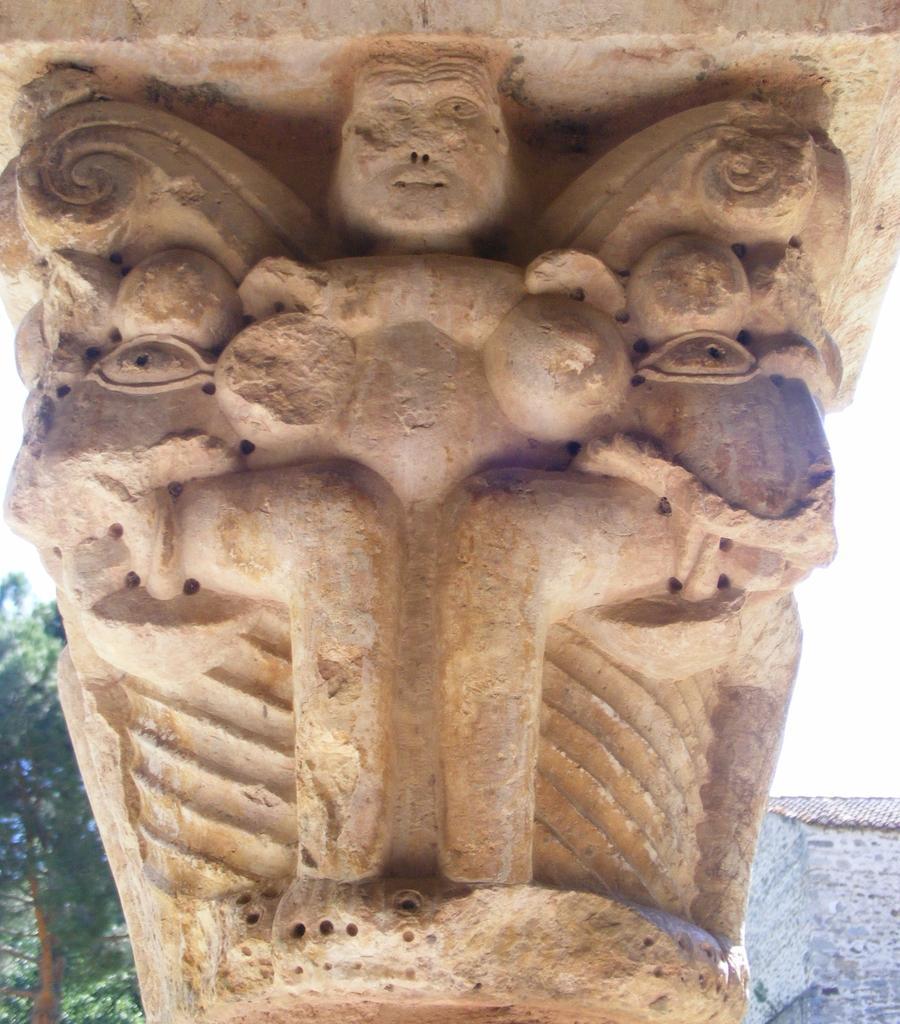Can you describe this image briefly? In this picture we can see a sculpture and in the background we can see trees,wall,sky. 